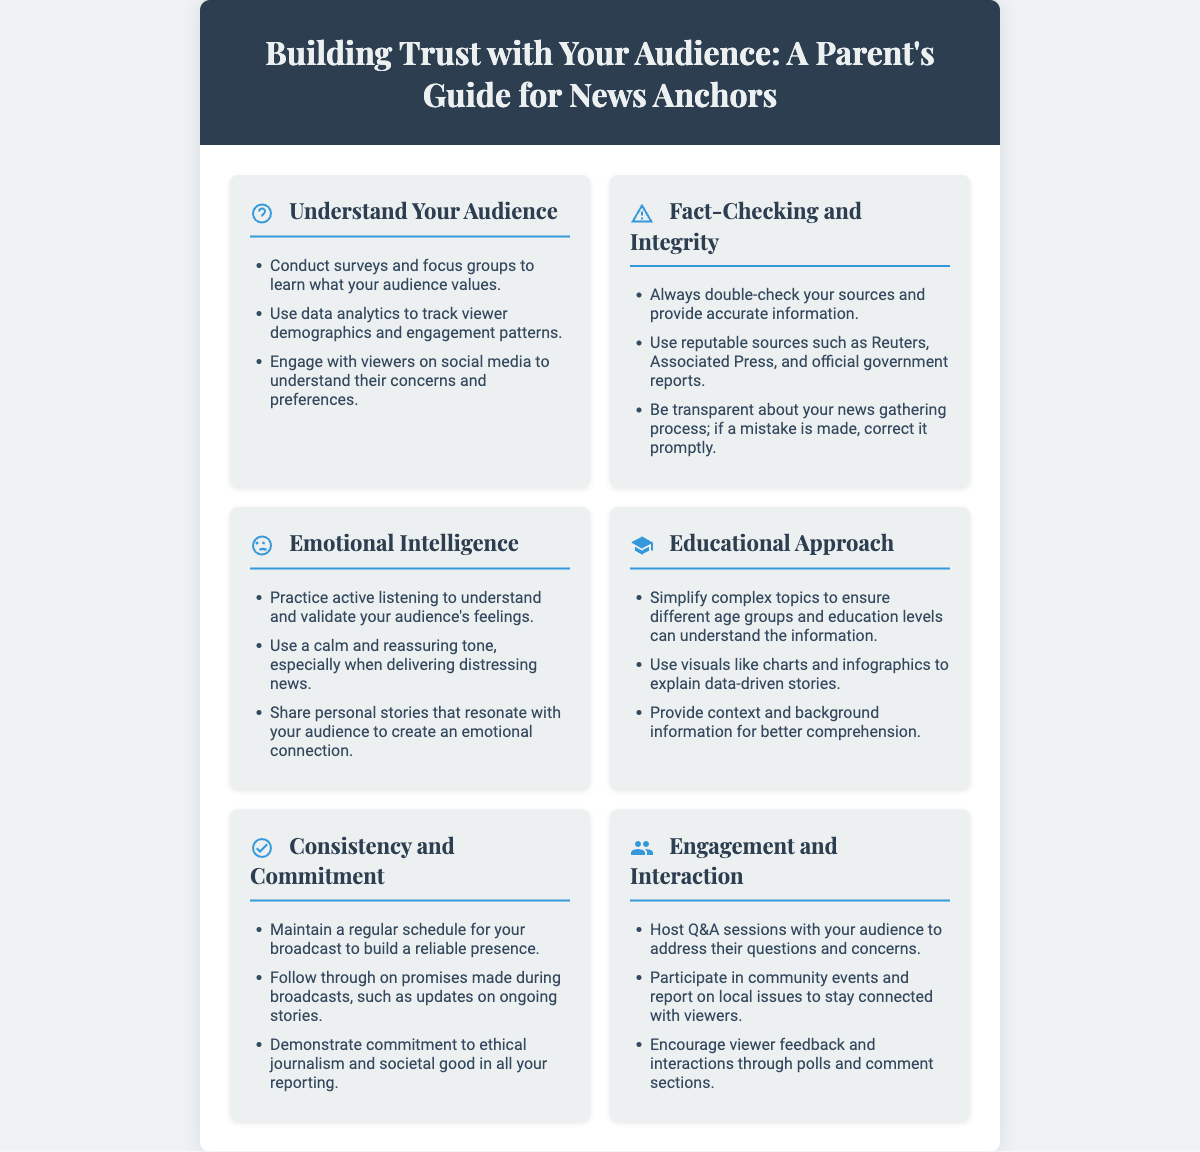What is the title of the poster? The title is prominently displayed at the top of the poster, introducing the theme of the document.
Answer: Building Trust with Your Audience: A Parent's Guide for News Anchors How many sections are there in the poster? The poster contains a total of seven distinct sections, each addressing different aspects of building trust.
Answer: Seven What is one method to understand your audience mentioned in the poster? The methods utilized to understand the audience are listed in the first section titled "Understand Your Audience."
Answer: Conduct surveys and focus groups Which reputable sources are suggested for fact-checking? The recommended reputable sources are identified in the second section titled "Fact-Checking and Integrity."
Answer: Reuters, Associated Press What tone should be used when delivering distressing news? The guidance on tone is provided in the section "Emotional Intelligence."
Answer: Calm and reassuring What is a key element of the educational approach described? The section "Educational Approach" outlines one of the key elements to simplify understanding for the audience.
Answer: Simplify complex topics How can anchors engage with their audience according to the poster? Engagement strategies are provided in the "Engagement and Interaction" section of the poster.
Answer: Host Q&A sessions What color is used for the header of the poster? The header's color is mentioned in the style information and visually represents the theme.
Answer: Dark blue 